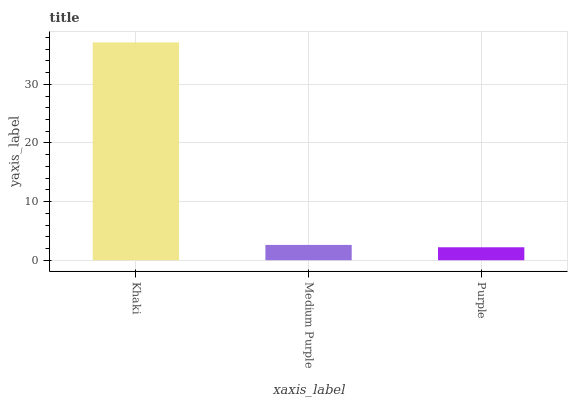Is Purple the minimum?
Answer yes or no. Yes. Is Khaki the maximum?
Answer yes or no. Yes. Is Medium Purple the minimum?
Answer yes or no. No. Is Medium Purple the maximum?
Answer yes or no. No. Is Khaki greater than Medium Purple?
Answer yes or no. Yes. Is Medium Purple less than Khaki?
Answer yes or no. Yes. Is Medium Purple greater than Khaki?
Answer yes or no. No. Is Khaki less than Medium Purple?
Answer yes or no. No. Is Medium Purple the high median?
Answer yes or no. Yes. Is Medium Purple the low median?
Answer yes or no. Yes. Is Purple the high median?
Answer yes or no. No. Is Purple the low median?
Answer yes or no. No. 